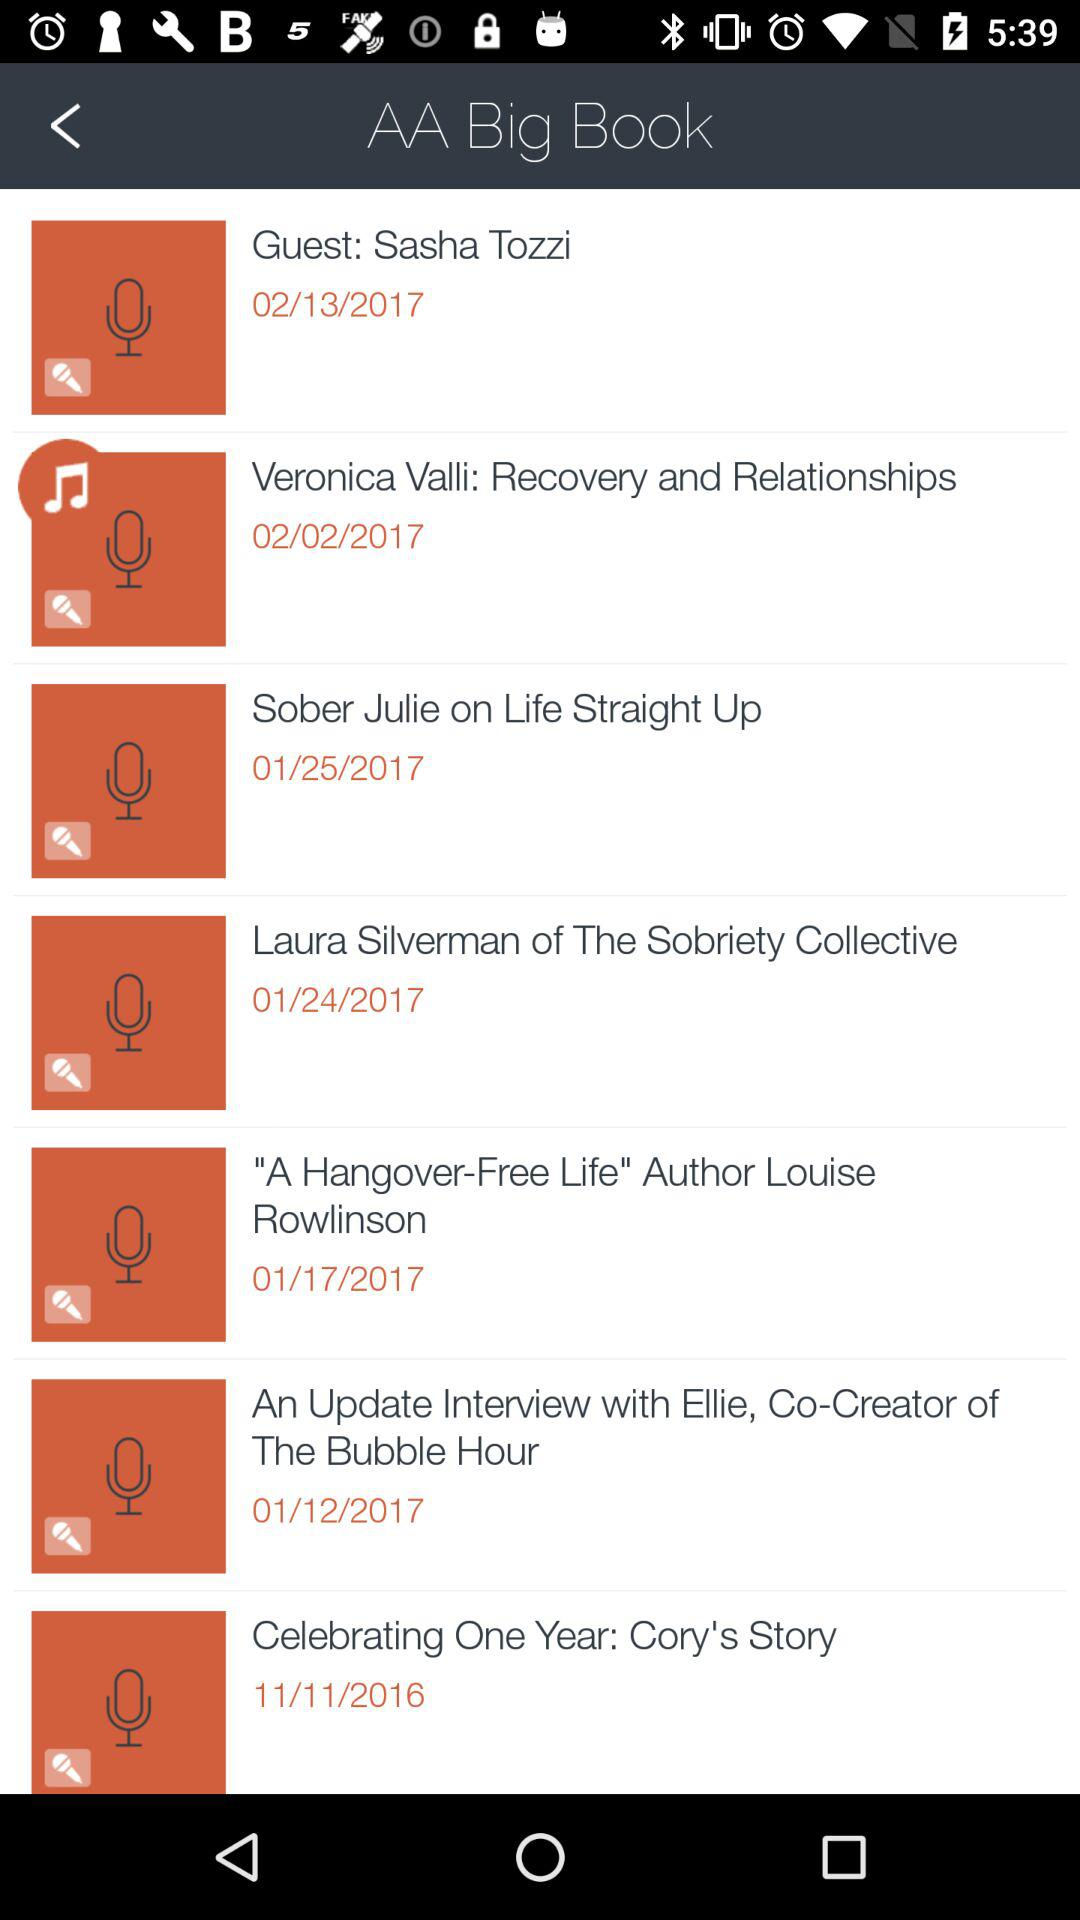What is the date of "Celebrating One Year: Cory's Story"? The date is 11/11/2016. 